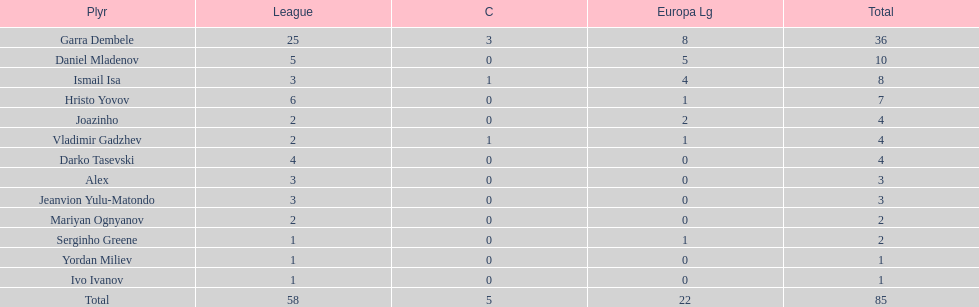Which player is in the same league as joazinho and vladimir gadzhev? Mariyan Ognyanov. 